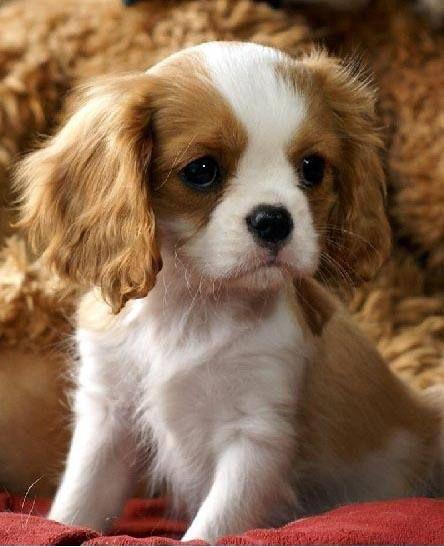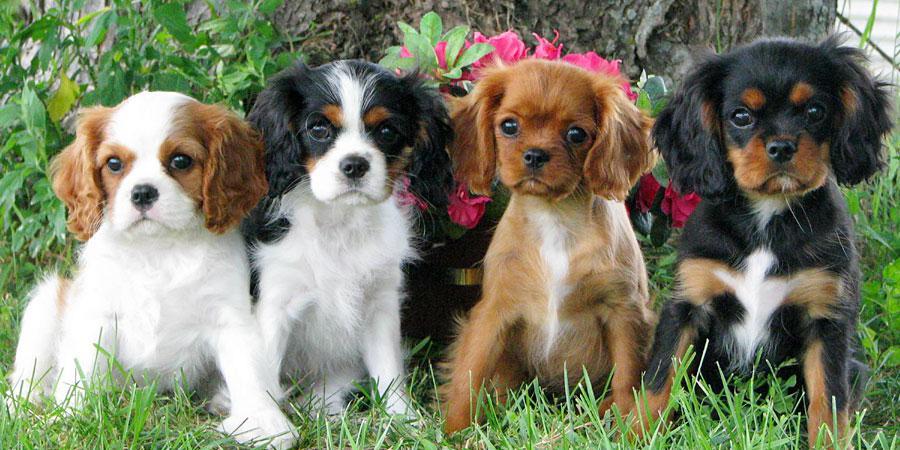The first image is the image on the left, the second image is the image on the right. For the images shown, is this caption "There is at most 2 dogs." true? Answer yes or no. No. The first image is the image on the left, the second image is the image on the right. Analyze the images presented: Is the assertion "There is at least one image that shows exactly one dog in the grass." valid? Answer yes or no. No. 